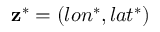Convert formula to latex. <formula><loc_0><loc_0><loc_500><loc_500>z ^ { \ast } = ( l o n ^ { \ast } , l a t ^ { \ast } )</formula> 